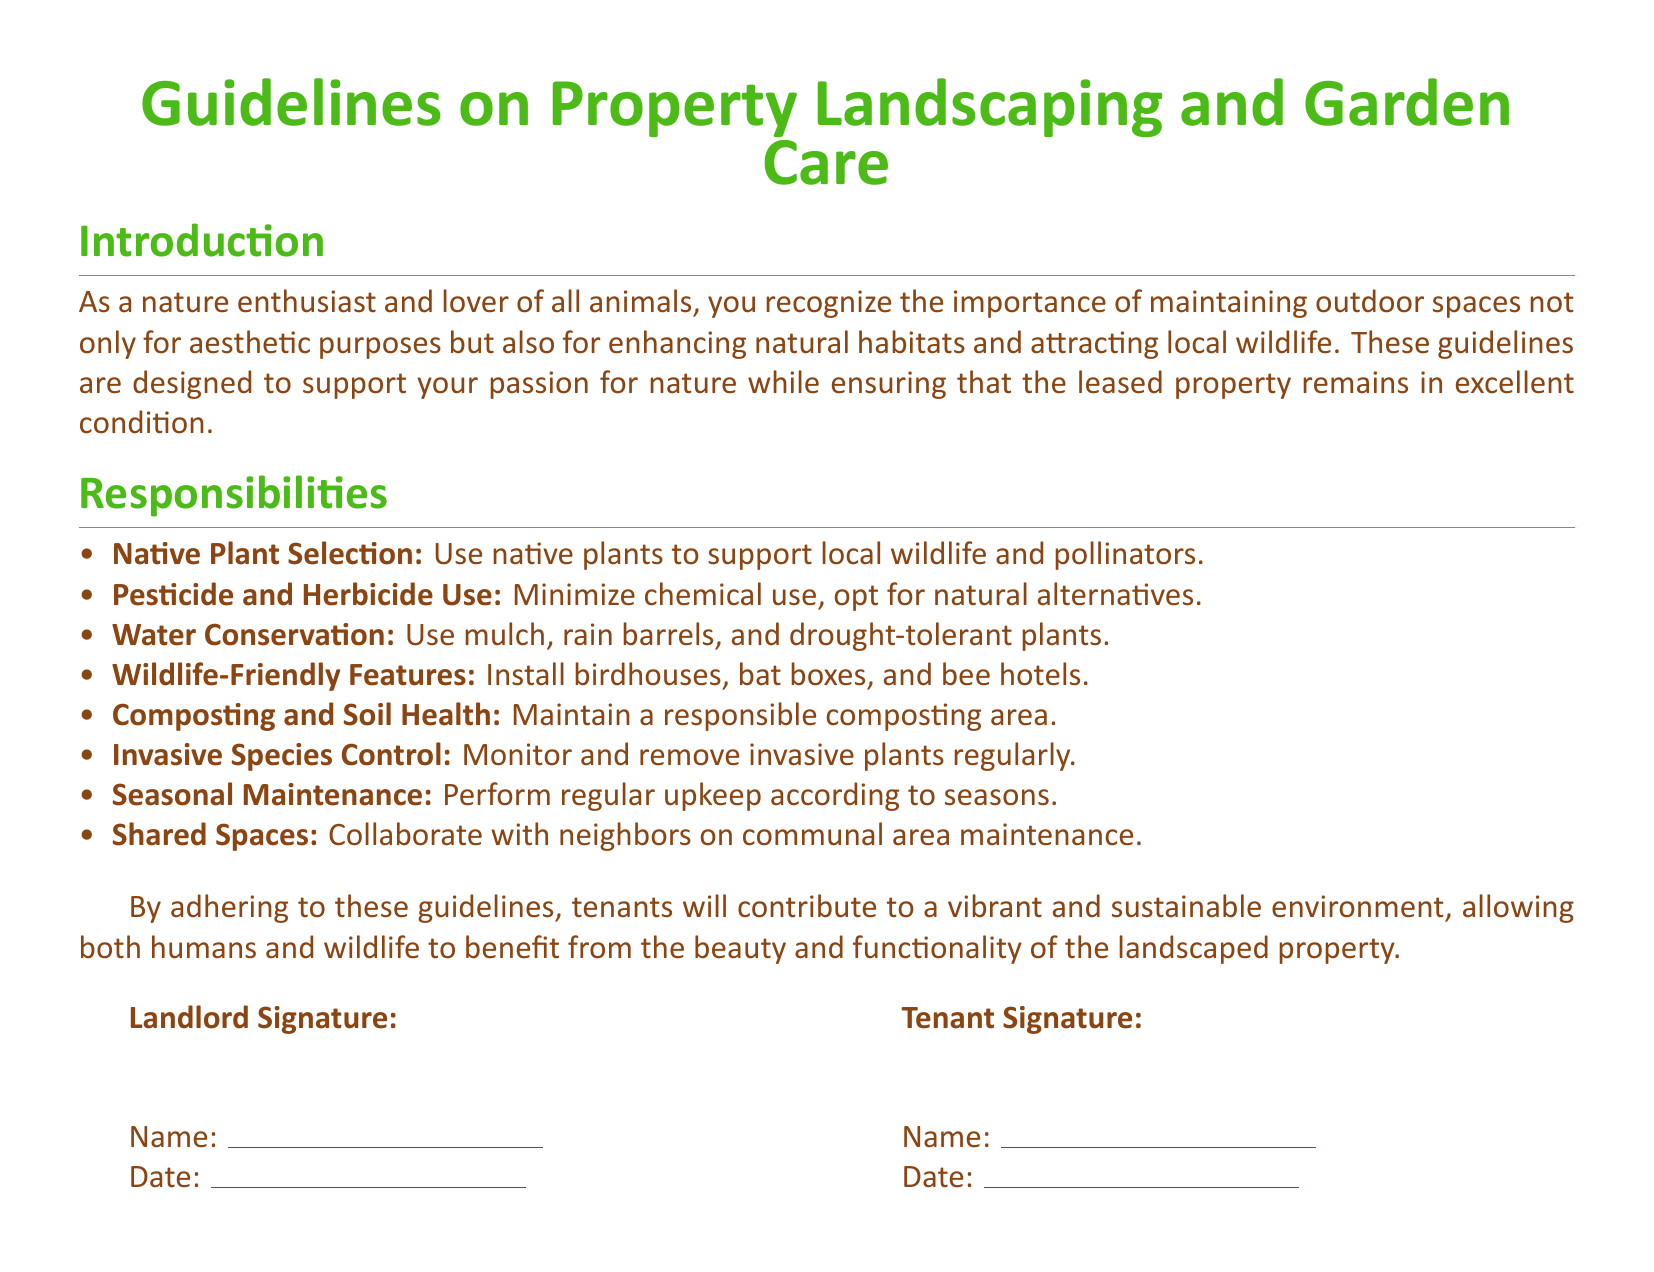What is the title of the document? The title is the main heading that indicates the content of the document, which is "Guidelines on Property Landscaping and Garden Care."
Answer: Guidelines on Property Landscaping and Garden Care How many sections are there in the document? The document contains an introduction and a responsibilities section, making it a total of 2 sections.
Answer: 2 What is one responsibility related to wildlife? The document lists various responsibilities concerning wildlife, one of which is to "install birdhouses, bat boxes, and bee hotels."
Answer: Install birdhouses, bat boxes, and bee hotels Which type of species should be monitored and removed? The guidelines specifically mention that invasive species should be watched for and taken out regularly.
Answer: Invasive plants What is suggested for water conservation? The document recommends using mulch, rain barrels, and drought-tolerant plants as part of water conservation efforts.
Answer: Use mulch, rain barrels, and drought-tolerant plants Who needs to sign the document? The document requires signatures from both the landlord and the tenant, indicating mutual agreement on the guidelines.
Answer: Landlord and Tenant What should be maintained to support soil health? The guidelines emphasize the importance of a responsible composting area to help maintain soil health.
Answer: Responsible composting area Which color is used for the main text in the document? The main text color defined in the document is brown, specifically referred to as "naturebrown."
Answer: naturebrown 